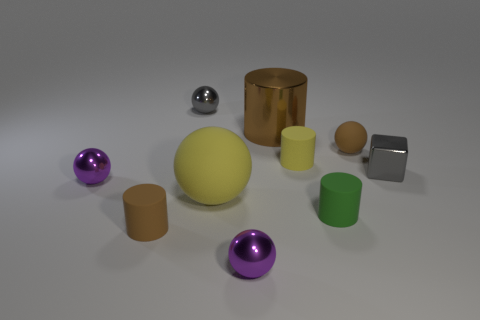How many yellow things have the same material as the green cylinder?
Make the answer very short. 2. Is the small yellow matte object the same shape as the large yellow thing?
Provide a short and direct response. No. How big is the gray metal object behind the gray object on the right side of the gray metal object that is left of the block?
Make the answer very short. Small. There is a small purple object that is in front of the green thing; is there a tiny cube behind it?
Ensure brevity in your answer.  Yes. How many tiny metal objects are in front of the tiny purple object that is behind the tiny cylinder that is on the left side of the gray ball?
Give a very brief answer. 1. The metal ball that is in front of the large cylinder and on the right side of the tiny brown rubber cylinder is what color?
Offer a very short reply. Purple. How many metal things have the same color as the small rubber ball?
Your answer should be very brief. 1. How many spheres are either tiny blue matte objects or big metallic objects?
Provide a short and direct response. 0. What color is the matte sphere that is the same size as the gray shiny block?
Offer a very short reply. Brown. Is there a large yellow rubber thing that is in front of the brown matte object in front of the small gray shiny thing right of the yellow rubber cylinder?
Keep it short and to the point. No. 